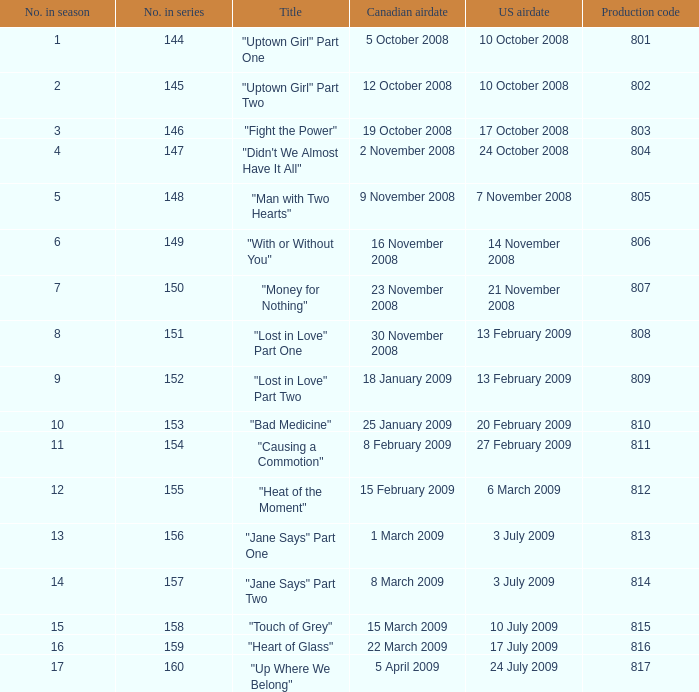What is the up-to-date season number for a show having a production code of 816? 16.0. 